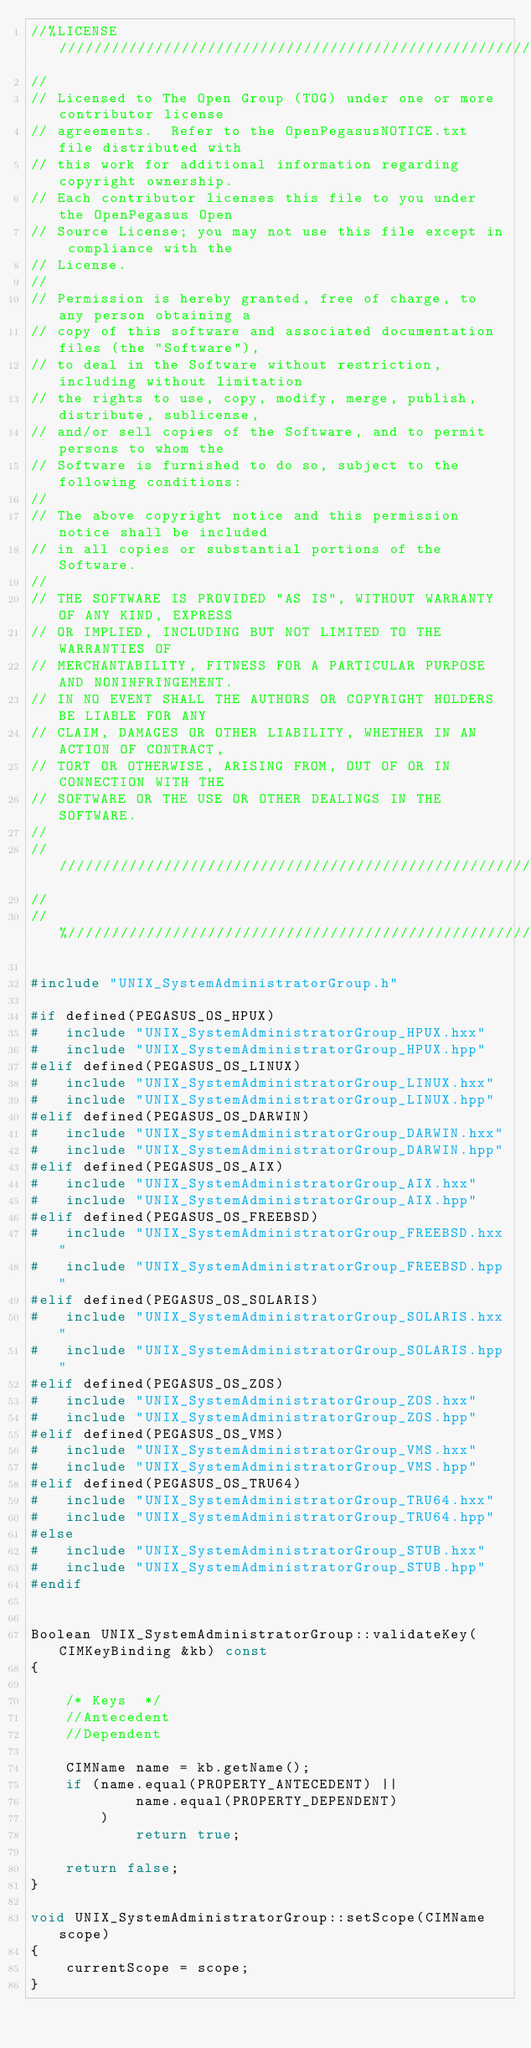<code> <loc_0><loc_0><loc_500><loc_500><_C++_>//%LICENSE////////////////////////////////////////////////////////////////
//
// Licensed to The Open Group (TOG) under one or more contributor license
// agreements.  Refer to the OpenPegasusNOTICE.txt file distributed with
// this work for additional information regarding copyright ownership.
// Each contributor licenses this file to you under the OpenPegasus Open
// Source License; you may not use this file except in compliance with the
// License.
//
// Permission is hereby granted, free of charge, to any person obtaining a
// copy of this software and associated documentation files (the "Software"),
// to deal in the Software without restriction, including without limitation
// the rights to use, copy, modify, merge, publish, distribute, sublicense,
// and/or sell copies of the Software, and to permit persons to whom the
// Software is furnished to do so, subject to the following conditions:
//
// The above copyright notice and this permission notice shall be included
// in all copies or substantial portions of the Software.
//
// THE SOFTWARE IS PROVIDED "AS IS", WITHOUT WARRANTY OF ANY KIND, EXPRESS
// OR IMPLIED, INCLUDING BUT NOT LIMITED TO THE WARRANTIES OF
// MERCHANTABILITY, FITNESS FOR A PARTICULAR PURPOSE AND NONINFRINGEMENT.
// IN NO EVENT SHALL THE AUTHORS OR COPYRIGHT HOLDERS BE LIABLE FOR ANY
// CLAIM, DAMAGES OR OTHER LIABILITY, WHETHER IN AN ACTION OF CONTRACT,
// TORT OR OTHERWISE, ARISING FROM, OUT OF OR IN CONNECTION WITH THE
// SOFTWARE OR THE USE OR OTHER DEALINGS IN THE SOFTWARE.
//
//////////////////////////////////////////////////////////////////////////
//
//%/////////////////////////////////////////////////////////////////////////

#include "UNIX_SystemAdministratorGroup.h"

#if defined(PEGASUS_OS_HPUX)
#	include "UNIX_SystemAdministratorGroup_HPUX.hxx"
#	include "UNIX_SystemAdministratorGroup_HPUX.hpp"
#elif defined(PEGASUS_OS_LINUX)
#	include "UNIX_SystemAdministratorGroup_LINUX.hxx"
#	include "UNIX_SystemAdministratorGroup_LINUX.hpp"
#elif defined(PEGASUS_OS_DARWIN)
#	include "UNIX_SystemAdministratorGroup_DARWIN.hxx"
#	include "UNIX_SystemAdministratorGroup_DARWIN.hpp"
#elif defined(PEGASUS_OS_AIX)
#	include "UNIX_SystemAdministratorGroup_AIX.hxx"
#	include "UNIX_SystemAdministratorGroup_AIX.hpp"
#elif defined(PEGASUS_OS_FREEBSD)
#	include "UNIX_SystemAdministratorGroup_FREEBSD.hxx"
#	include "UNIX_SystemAdministratorGroup_FREEBSD.hpp"
#elif defined(PEGASUS_OS_SOLARIS)
#	include "UNIX_SystemAdministratorGroup_SOLARIS.hxx"
#	include "UNIX_SystemAdministratorGroup_SOLARIS.hpp"
#elif defined(PEGASUS_OS_ZOS)
#	include "UNIX_SystemAdministratorGroup_ZOS.hxx"
#	include "UNIX_SystemAdministratorGroup_ZOS.hpp"
#elif defined(PEGASUS_OS_VMS)
#	include "UNIX_SystemAdministratorGroup_VMS.hxx"
#	include "UNIX_SystemAdministratorGroup_VMS.hpp"
#elif defined(PEGASUS_OS_TRU64)
#	include "UNIX_SystemAdministratorGroup_TRU64.hxx"
#	include "UNIX_SystemAdministratorGroup_TRU64.hpp"
#else
#	include "UNIX_SystemAdministratorGroup_STUB.hxx"
#	include "UNIX_SystemAdministratorGroup_STUB.hpp"
#endif


Boolean UNIX_SystemAdministratorGroup::validateKey(CIMKeyBinding &kb) const
{

	/* Keys  */
	//Antecedent
	//Dependent

	CIMName name = kb.getName();
	if (name.equal(PROPERTY_ANTECEDENT) ||
			name.equal(PROPERTY_DEPENDENT)
		)
			return true;

	return false;
}

void UNIX_SystemAdministratorGroup::setScope(CIMName scope)
{
	currentScope = scope;
}

</code> 